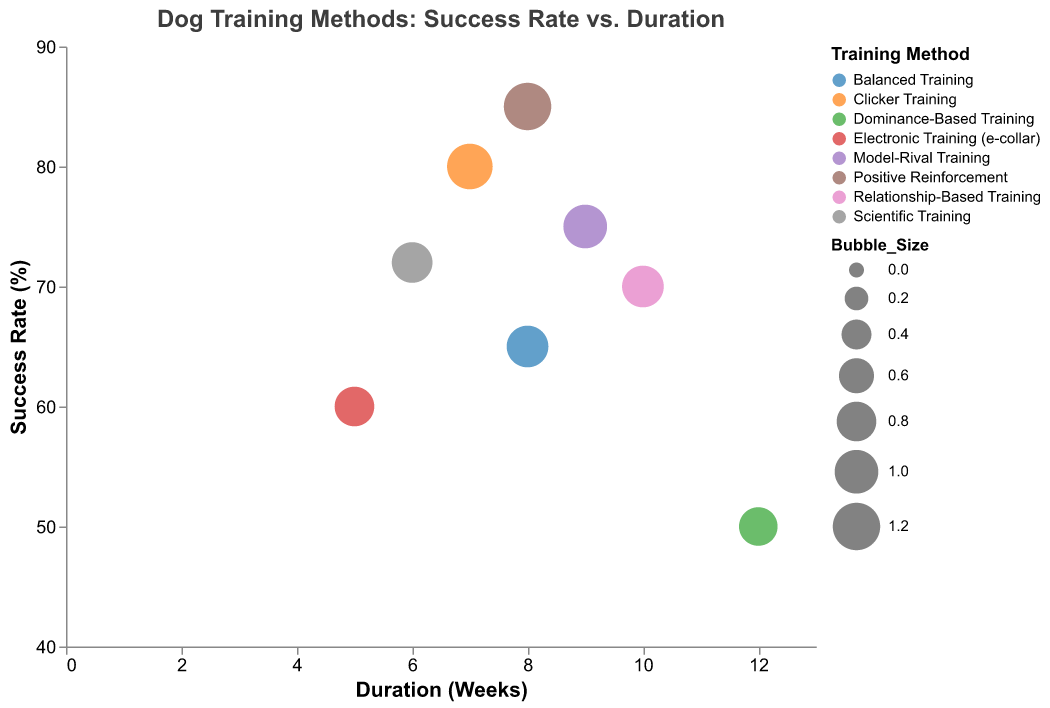What is the success rate of Positive Reinforcement training? Look at the y-axis value associated with the 'Positive Reinforcement' bubble in the figure. The success rate is listed dort.
Answer: 85% Which training method has the longest duration? Find the bubble associated with the largest x-axis value (Duration in Weeks). The training method with the longest duration is associated with that bubble.
Answer: Dominance-Based Training What is the difference in success rate between Electronic Training and Clicker Training? Look at the y-axis values for both 'Electronic Training (e-collar)' and 'Clicker Training'. The values are 60% and 80%, respectively. The difference is 80% - 60% = 20%.
Answer: 20% Which training methods have a duration of 8 weeks? Find the bubbles positioned at 'Duration (Weeks)' = 8 on the x-axis. The methods associated with those bubbles are 'Positive Reinforcement' and 'Balanced Training'.
Answer: Positive Reinforcement, Balanced Training Which training method has the highest success rate? Look for the bubble positioned at the highest y-axis value (Success Rate). The training method associated with that bubble is 'Positive Reinforcement'.
Answer: Positive Reinforcement Compare the success rates of the two training methods with the same duration of 8 weeks. Which one is higher? Look at the bubbles at x-axis value 8 and compare their y-axis values. 'Positive Reinforcement' has a success rate of 85%, and 'Balanced Training' has a success rate of 65%. 'Positive Reinforcement' has the higher success rate.
Answer: Positive Reinforcement How does the duration of Relationship-Based Training compare to Scientific Training? Locate the bubbles for 'Relationship-Based Training' and 'Scientific Training' and compare their x-axis values. 'Relationship-Based Training' has a duration of 10 weeks whereas 'Scientific Training' has 6 weeks.
Answer: Relationship-Based Training is longer What training method corresponds to the largest bubble? Look at the figure and identify the largest bubble by its size. The 'Positive Reinforcement' method is associated with the largest bubble.
Answer: Positive Reinforcement Which training method has both the lowest success rate and the longest duration? The bubble with the lowest success rate (smallest y-axis value) and the longest duration (largest x-axis value) is 'Dominance-Based Training' with a 50% success rate and 12 weeks duration.
Answer: Dominance-Based Training 